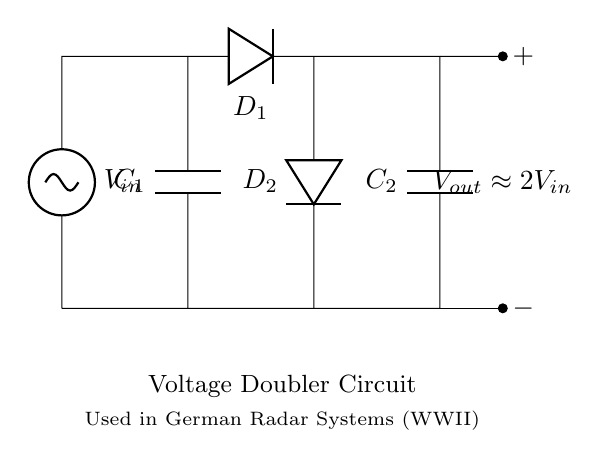What is the input voltage of this circuit? The input voltage is represented by the label V_{in} in the circuit, indicating the voltage supplied to the circuit.
Answer: V_{in} How many capacitors are present in this circuit? The circuit diagram shows two capacitors labeled as C_1 and C_2, which are used in the voltage doubling process.
Answer: 2 What is the output voltage relation in this circuit? The output voltage, denoted as V_{out}, is approximately double the input voltage, as indicated in the labeling of the circuit.
Answer: V_{out} approximately 2V_{in} What is the purpose of the diodes in this circuit? The diodes D_1 and D_2 are used for rectification, allowing current to flow in one direction and thus charging the capacitors during the alternation of the input voltage.
Answer: Rectification Explain how the voltage doubling occurs in this circuit. The voltage doubling occurs because as the input AC voltage varies, the capacitors charge up sequentially through the diodes. During one half of the AC cycle, one capacitor is charged and during the next half, both capacitors contribute to doubling the output voltage to the load.
Answer: Charging sequence of capacitors What type of circuit is this? The circuit is identified as a voltage doubler circuit because it effectively doubles the input voltage through the configuration of its components.
Answer: Voltage doubler circuit 